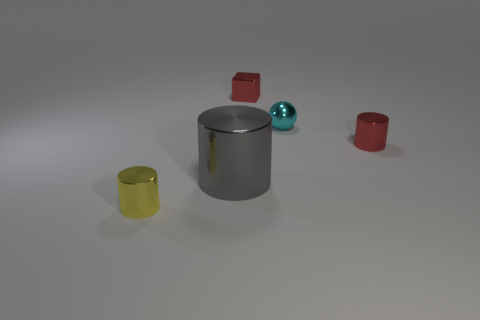Add 1 purple things. How many objects exist? 6 Subtract all cylinders. How many objects are left? 2 Add 5 red things. How many red things are left? 7 Add 1 big purple things. How many big purple things exist? 1 Subtract 0 blue cylinders. How many objects are left? 5 Subtract all small purple rubber blocks. Subtract all red things. How many objects are left? 3 